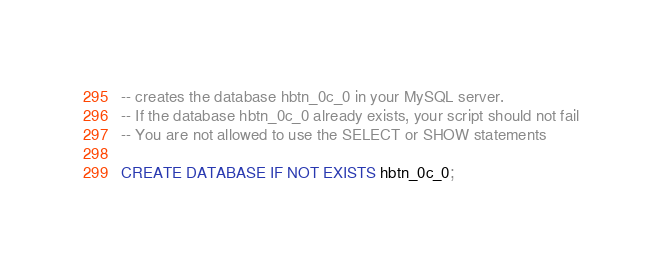Convert code to text. <code><loc_0><loc_0><loc_500><loc_500><_SQL_>-- creates the database hbtn_0c_0 in your MySQL server.
-- If the database hbtn_0c_0 already exists, your script should not fail
-- You are not allowed to use the SELECT or SHOW statements

CREATE DATABASE IF NOT EXISTS hbtn_0c_0;
</code> 